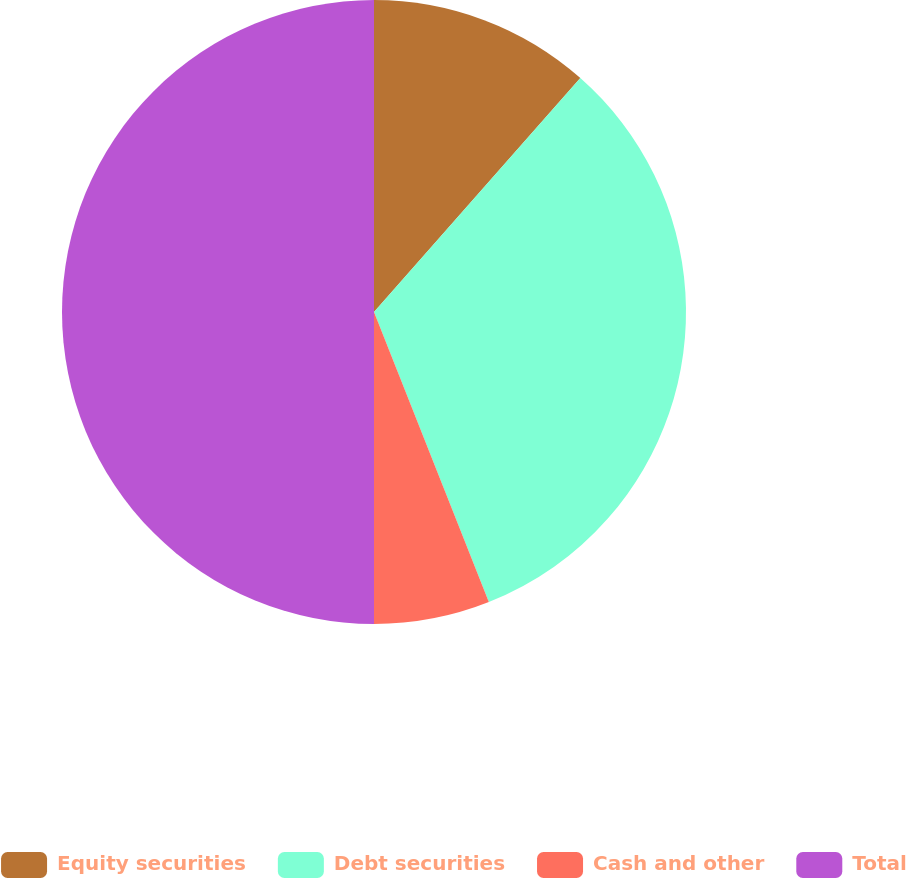Convert chart to OTSL. <chart><loc_0><loc_0><loc_500><loc_500><pie_chart><fcel>Equity securities<fcel>Debt securities<fcel>Cash and other<fcel>Total<nl><fcel>11.5%<fcel>32.5%<fcel>6.0%<fcel>50.0%<nl></chart> 